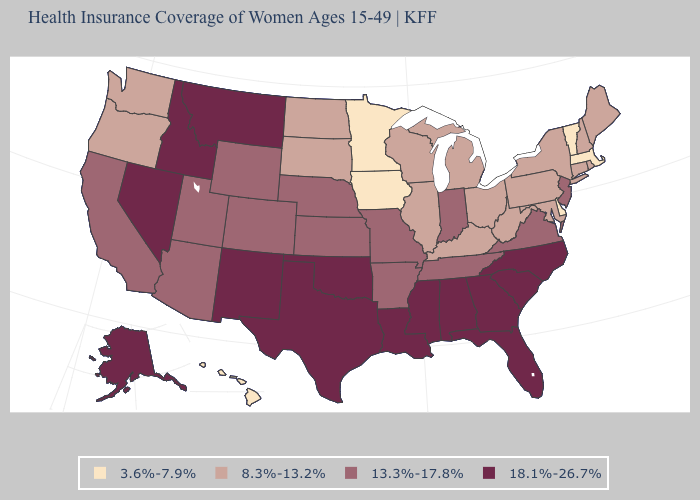Which states have the highest value in the USA?
Short answer required. Alabama, Alaska, Florida, Georgia, Idaho, Louisiana, Mississippi, Montana, Nevada, New Mexico, North Carolina, Oklahoma, South Carolina, Texas. What is the value of Kansas?
Concise answer only. 13.3%-17.8%. Which states have the highest value in the USA?
Write a very short answer. Alabama, Alaska, Florida, Georgia, Idaho, Louisiana, Mississippi, Montana, Nevada, New Mexico, North Carolina, Oklahoma, South Carolina, Texas. What is the value of Ohio?
Write a very short answer. 8.3%-13.2%. What is the value of Washington?
Short answer required. 8.3%-13.2%. What is the lowest value in the MidWest?
Give a very brief answer. 3.6%-7.9%. Which states have the highest value in the USA?
Answer briefly. Alabama, Alaska, Florida, Georgia, Idaho, Louisiana, Mississippi, Montana, Nevada, New Mexico, North Carolina, Oklahoma, South Carolina, Texas. What is the value of California?
Give a very brief answer. 13.3%-17.8%. Among the states that border Alabama , does Georgia have the lowest value?
Answer briefly. No. Does Delaware have the lowest value in the USA?
Short answer required. Yes. Which states hav the highest value in the MidWest?
Concise answer only. Indiana, Kansas, Missouri, Nebraska. Among the states that border Utah , does Nevada have the highest value?
Write a very short answer. Yes. Does Minnesota have the same value as Connecticut?
Be succinct. No. Is the legend a continuous bar?
Quick response, please. No. 